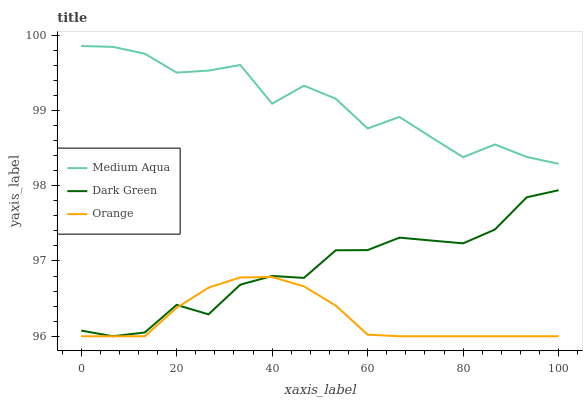Does Orange have the minimum area under the curve?
Answer yes or no. Yes. Does Medium Aqua have the maximum area under the curve?
Answer yes or no. Yes. Does Dark Green have the minimum area under the curve?
Answer yes or no. No. Does Dark Green have the maximum area under the curve?
Answer yes or no. No. Is Orange the smoothest?
Answer yes or no. Yes. Is Medium Aqua the roughest?
Answer yes or no. Yes. Is Dark Green the smoothest?
Answer yes or no. No. Is Dark Green the roughest?
Answer yes or no. No. Does Orange have the lowest value?
Answer yes or no. Yes. Does Medium Aqua have the lowest value?
Answer yes or no. No. Does Medium Aqua have the highest value?
Answer yes or no. Yes. Does Dark Green have the highest value?
Answer yes or no. No. Is Dark Green less than Medium Aqua?
Answer yes or no. Yes. Is Medium Aqua greater than Dark Green?
Answer yes or no. Yes. Does Orange intersect Dark Green?
Answer yes or no. Yes. Is Orange less than Dark Green?
Answer yes or no. No. Is Orange greater than Dark Green?
Answer yes or no. No. Does Dark Green intersect Medium Aqua?
Answer yes or no. No. 